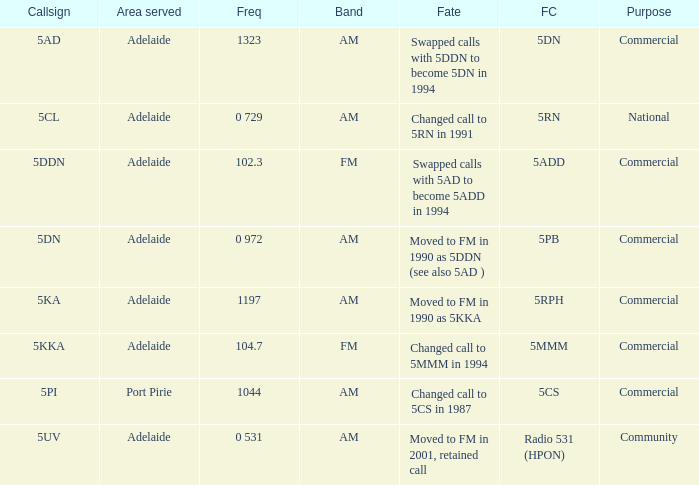What is the current freq for Frequency of 104.7? 5MMM. 